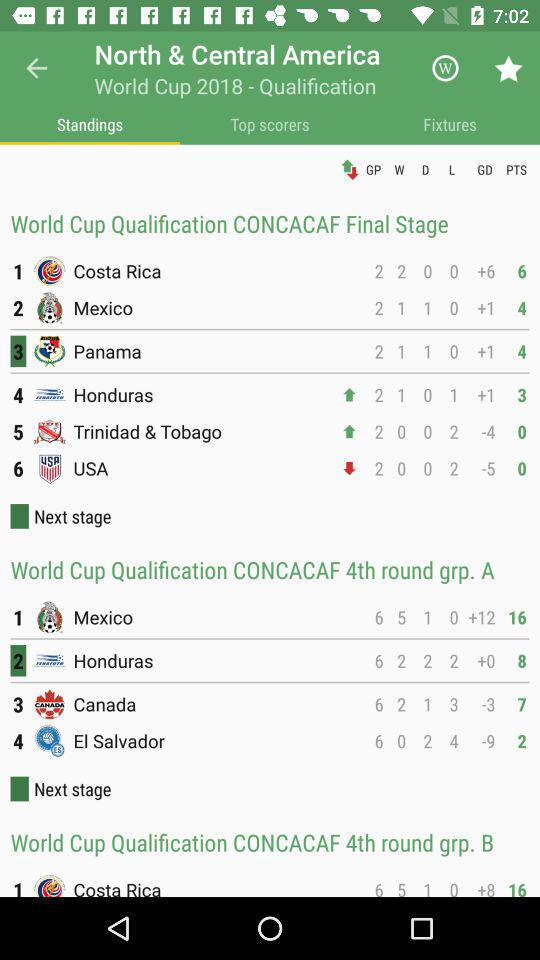Which tab has been selected? The selected tab is "Standings". 